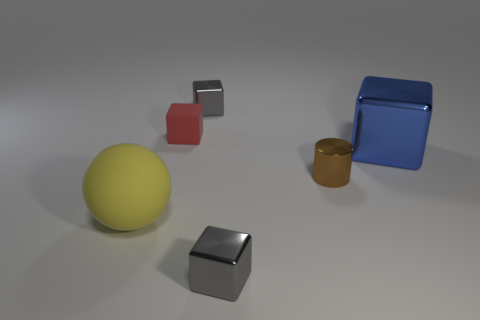Subtract all blue metal cubes. How many cubes are left? 3 Add 4 yellow shiny cylinders. How many objects exist? 10 Subtract all gray cubes. How many cubes are left? 2 Subtract all cylinders. How many objects are left? 5 Subtract 2 blocks. How many blocks are left? 2 Subtract all yellow cylinders. Subtract all blue balls. How many cylinders are left? 1 Subtract all green balls. How many purple cylinders are left? 0 Subtract all big yellow rubber things. Subtract all metal things. How many objects are left? 1 Add 4 tiny rubber things. How many tiny rubber things are left? 5 Add 6 small rubber things. How many small rubber things exist? 7 